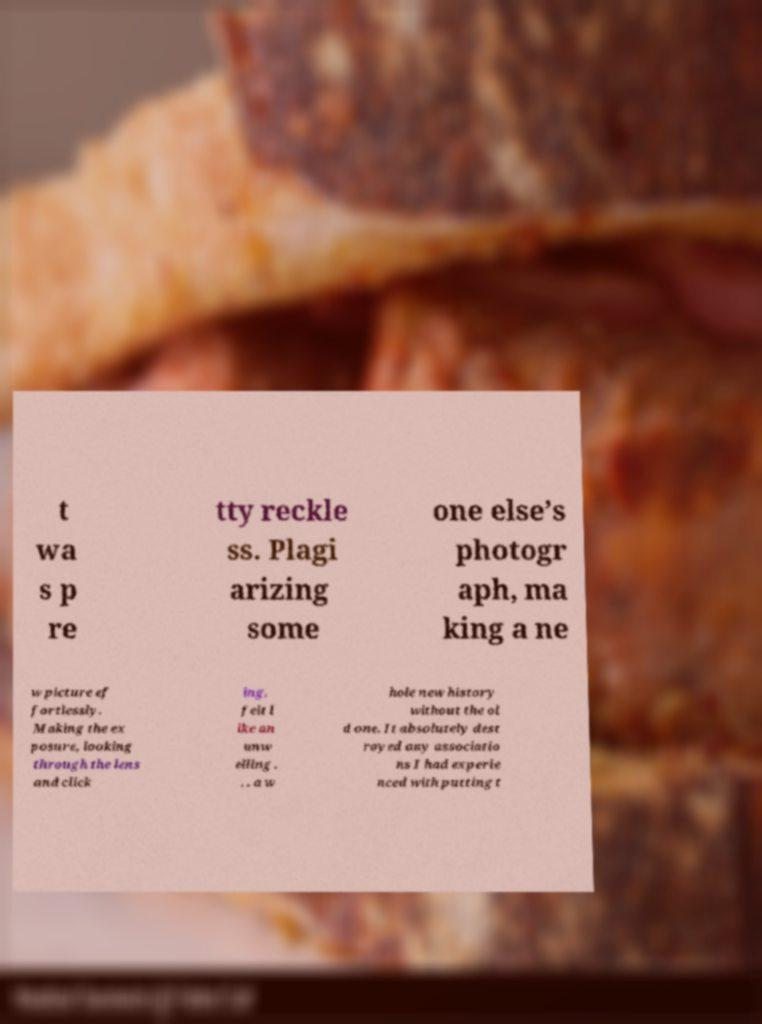Can you read and provide the text displayed in the image?This photo seems to have some interesting text. Can you extract and type it out for me? t wa s p re tty reckle ss. Plagi arizing some one else’s photogr aph, ma king a ne w picture ef fortlessly. Making the ex posure, looking through the lens and click ing, felt l ike an unw elling . . . a w hole new history without the ol d one. It absolutely dest royed any associatio ns I had experie nced with putting t 